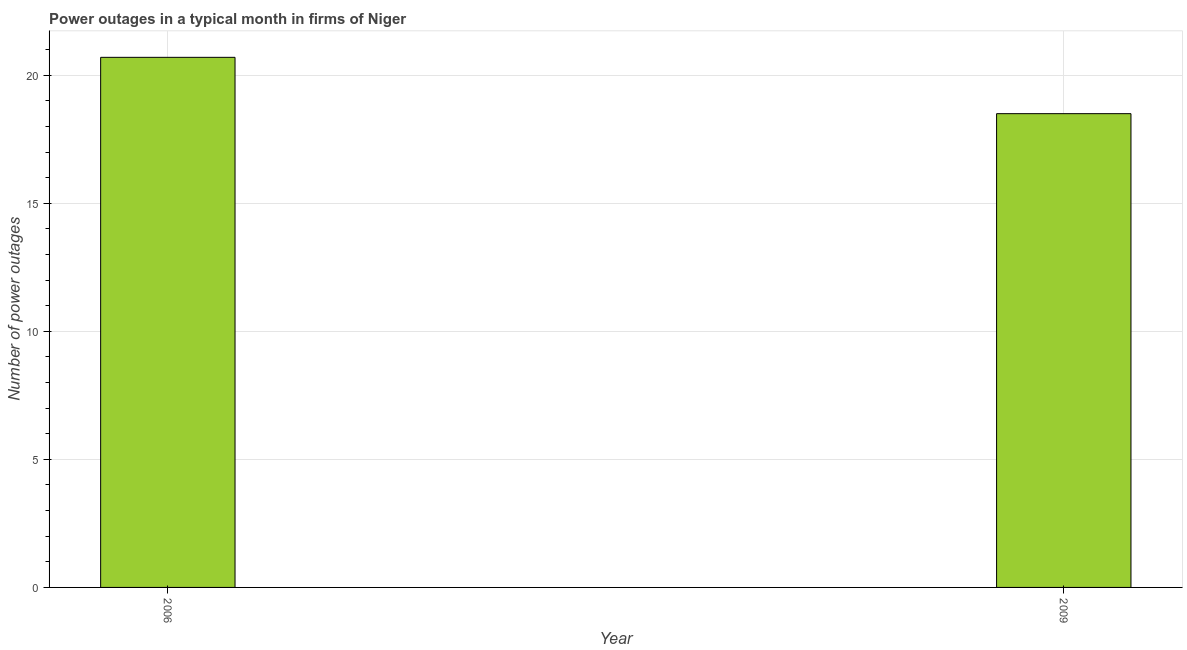What is the title of the graph?
Ensure brevity in your answer.  Power outages in a typical month in firms of Niger. What is the label or title of the Y-axis?
Keep it short and to the point. Number of power outages. What is the number of power outages in 2006?
Ensure brevity in your answer.  20.7. Across all years, what is the maximum number of power outages?
Keep it short and to the point. 20.7. What is the sum of the number of power outages?
Make the answer very short. 39.2. What is the difference between the number of power outages in 2006 and 2009?
Offer a terse response. 2.2. What is the average number of power outages per year?
Your answer should be very brief. 19.6. What is the median number of power outages?
Your response must be concise. 19.6. In how many years, is the number of power outages greater than 16 ?
Provide a succinct answer. 2. Do a majority of the years between 2009 and 2006 (inclusive) have number of power outages greater than 13 ?
Ensure brevity in your answer.  No. What is the ratio of the number of power outages in 2006 to that in 2009?
Your answer should be very brief. 1.12. In how many years, is the number of power outages greater than the average number of power outages taken over all years?
Your answer should be very brief. 1. Are all the bars in the graph horizontal?
Keep it short and to the point. No. What is the difference between two consecutive major ticks on the Y-axis?
Keep it short and to the point. 5. What is the Number of power outages of 2006?
Offer a very short reply. 20.7. What is the ratio of the Number of power outages in 2006 to that in 2009?
Provide a short and direct response. 1.12. 